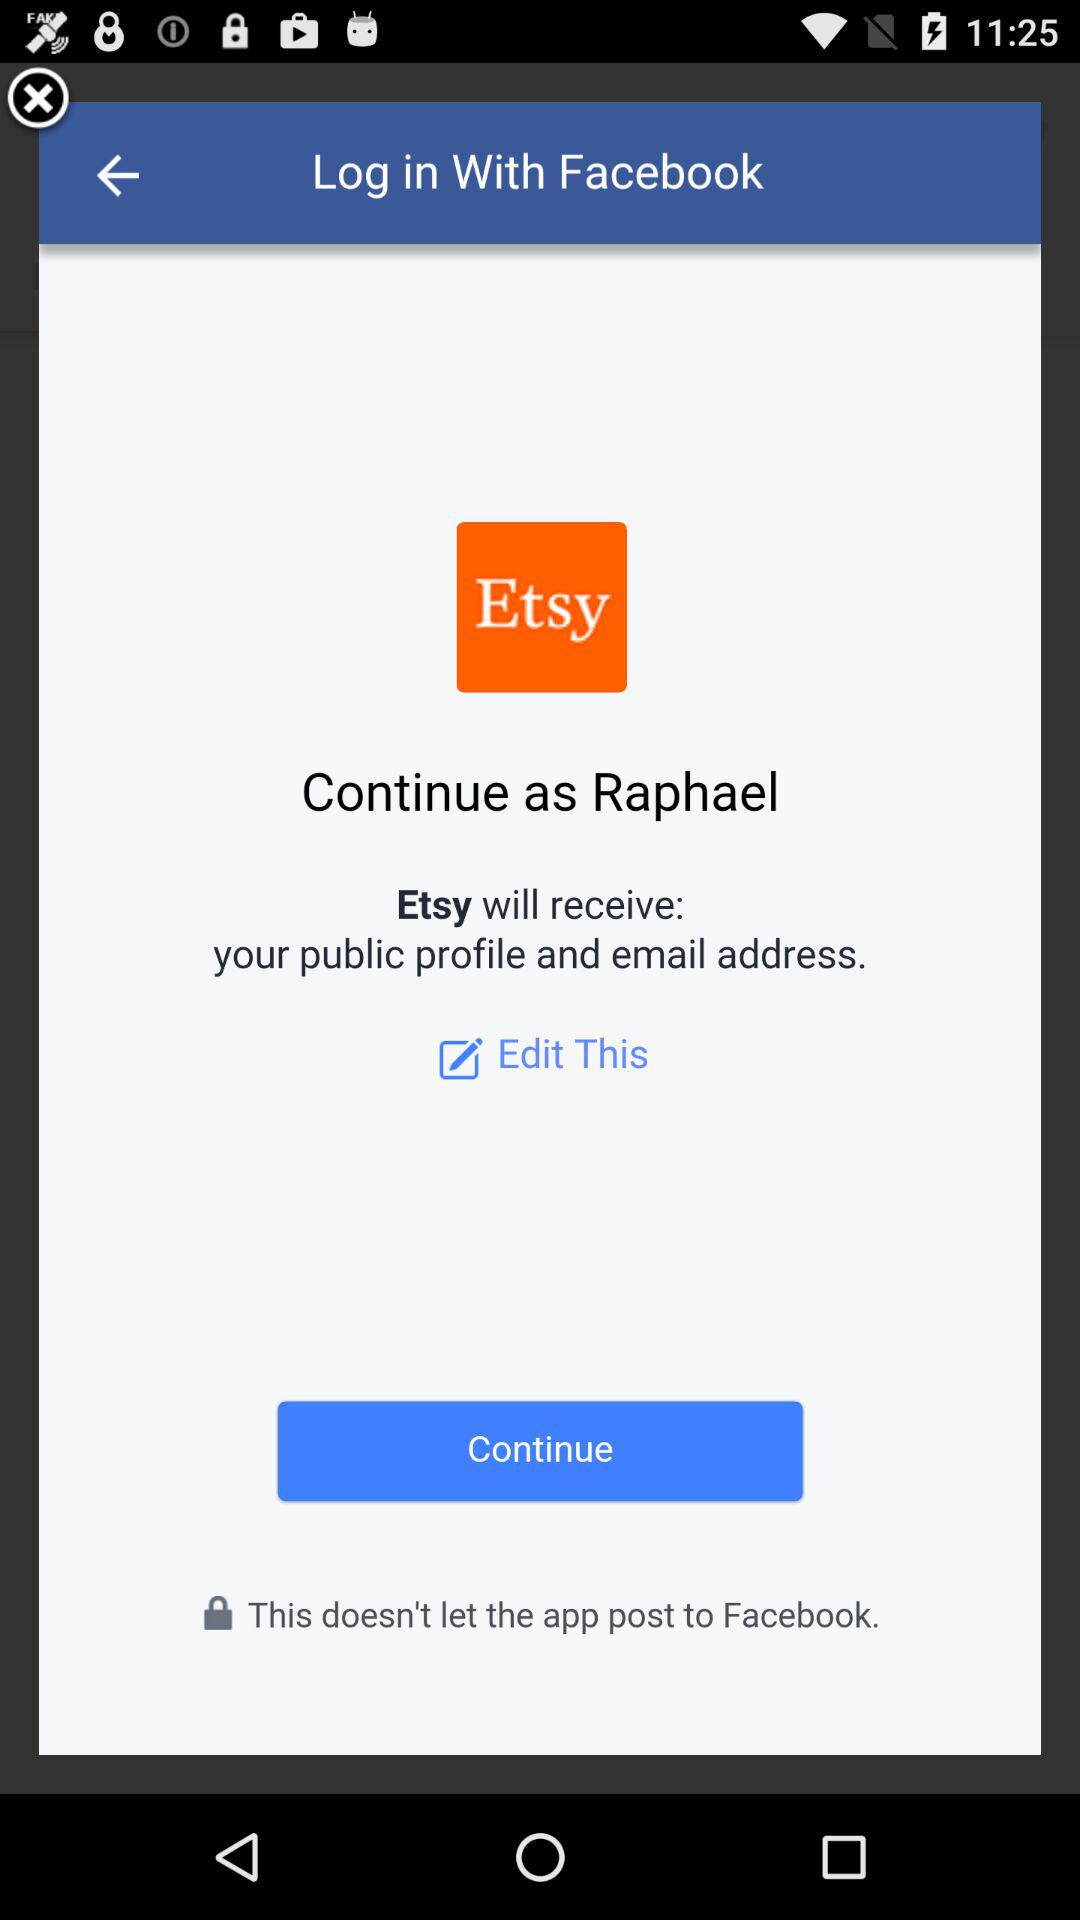Which option is selected?
When the provided information is insufficient, respond with <no answer>. <no answer> 